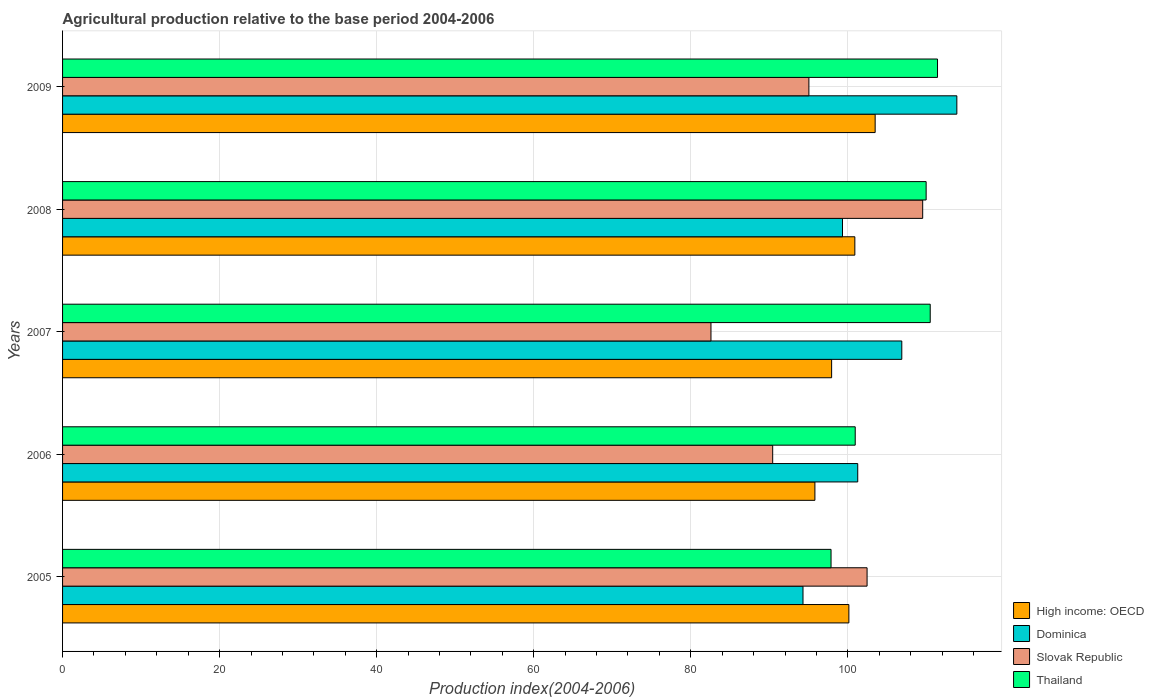How many groups of bars are there?
Your answer should be compact. 5. Are the number of bars per tick equal to the number of legend labels?
Keep it short and to the point. Yes. How many bars are there on the 3rd tick from the top?
Keep it short and to the point. 4. What is the agricultural production index in Slovak Republic in 2007?
Your answer should be compact. 82.57. Across all years, what is the maximum agricultural production index in Thailand?
Provide a succinct answer. 111.42. Across all years, what is the minimum agricultural production index in Dominica?
Provide a short and direct response. 94.29. In which year was the agricultural production index in Dominica minimum?
Offer a terse response. 2005. What is the total agricultural production index in Slovak Republic in the graph?
Offer a very short reply. 480.02. What is the difference between the agricultural production index in Slovak Republic in 2005 and that in 2009?
Your answer should be very brief. 7.41. What is the difference between the agricultural production index in Dominica in 2006 and the agricultural production index in High income: OECD in 2009?
Make the answer very short. -2.22. What is the average agricultural production index in Slovak Republic per year?
Keep it short and to the point. 96. In the year 2007, what is the difference between the agricultural production index in Thailand and agricultural production index in High income: OECD?
Offer a very short reply. 12.56. What is the ratio of the agricultural production index in Slovak Republic in 2005 to that in 2006?
Make the answer very short. 1.13. What is the difference between the highest and the second highest agricultural production index in Slovak Republic?
Your answer should be very brief. 7.08. What is the difference between the highest and the lowest agricultural production index in High income: OECD?
Provide a short and direct response. 7.67. Is it the case that in every year, the sum of the agricultural production index in High income: OECD and agricultural production index in Slovak Republic is greater than the sum of agricultural production index in Dominica and agricultural production index in Thailand?
Your answer should be compact. No. What does the 2nd bar from the top in 2005 represents?
Your answer should be very brief. Slovak Republic. What does the 4th bar from the bottom in 2009 represents?
Provide a short and direct response. Thailand. What is the difference between two consecutive major ticks on the X-axis?
Make the answer very short. 20. Are the values on the major ticks of X-axis written in scientific E-notation?
Ensure brevity in your answer.  No. Does the graph contain grids?
Your answer should be very brief. Yes. How many legend labels are there?
Your answer should be very brief. 4. What is the title of the graph?
Give a very brief answer. Agricultural production relative to the base period 2004-2006. Does "Congo (Republic)" appear as one of the legend labels in the graph?
Keep it short and to the point. No. What is the label or title of the X-axis?
Offer a terse response. Production index(2004-2006). What is the Production index(2004-2006) in High income: OECD in 2005?
Your answer should be very brief. 100.13. What is the Production index(2004-2006) of Dominica in 2005?
Ensure brevity in your answer.  94.29. What is the Production index(2004-2006) of Slovak Republic in 2005?
Your answer should be compact. 102.45. What is the Production index(2004-2006) in Thailand in 2005?
Provide a succinct answer. 97.86. What is the Production index(2004-2006) in High income: OECD in 2006?
Your response must be concise. 95.81. What is the Production index(2004-2006) of Dominica in 2006?
Make the answer very short. 101.26. What is the Production index(2004-2006) in Slovak Republic in 2006?
Make the answer very short. 90.43. What is the Production index(2004-2006) of Thailand in 2006?
Offer a very short reply. 100.94. What is the Production index(2004-2006) of High income: OECD in 2007?
Give a very brief answer. 97.93. What is the Production index(2004-2006) in Dominica in 2007?
Make the answer very short. 106.87. What is the Production index(2004-2006) of Slovak Republic in 2007?
Keep it short and to the point. 82.57. What is the Production index(2004-2006) of Thailand in 2007?
Your response must be concise. 110.49. What is the Production index(2004-2006) of High income: OECD in 2008?
Keep it short and to the point. 100.89. What is the Production index(2004-2006) of Dominica in 2008?
Make the answer very short. 99.32. What is the Production index(2004-2006) of Slovak Republic in 2008?
Offer a very short reply. 109.53. What is the Production index(2004-2006) in Thailand in 2008?
Make the answer very short. 109.97. What is the Production index(2004-2006) of High income: OECD in 2009?
Offer a terse response. 103.48. What is the Production index(2004-2006) of Dominica in 2009?
Provide a short and direct response. 113.88. What is the Production index(2004-2006) in Slovak Republic in 2009?
Your answer should be compact. 95.04. What is the Production index(2004-2006) in Thailand in 2009?
Offer a very short reply. 111.42. Across all years, what is the maximum Production index(2004-2006) of High income: OECD?
Provide a succinct answer. 103.48. Across all years, what is the maximum Production index(2004-2006) in Dominica?
Your response must be concise. 113.88. Across all years, what is the maximum Production index(2004-2006) of Slovak Republic?
Your response must be concise. 109.53. Across all years, what is the maximum Production index(2004-2006) in Thailand?
Offer a very short reply. 111.42. Across all years, what is the minimum Production index(2004-2006) of High income: OECD?
Give a very brief answer. 95.81. Across all years, what is the minimum Production index(2004-2006) of Dominica?
Ensure brevity in your answer.  94.29. Across all years, what is the minimum Production index(2004-2006) of Slovak Republic?
Offer a very short reply. 82.57. Across all years, what is the minimum Production index(2004-2006) of Thailand?
Provide a short and direct response. 97.86. What is the total Production index(2004-2006) in High income: OECD in the graph?
Your answer should be compact. 498.24. What is the total Production index(2004-2006) of Dominica in the graph?
Give a very brief answer. 515.62. What is the total Production index(2004-2006) in Slovak Republic in the graph?
Keep it short and to the point. 480.02. What is the total Production index(2004-2006) in Thailand in the graph?
Your response must be concise. 530.68. What is the difference between the Production index(2004-2006) in High income: OECD in 2005 and that in 2006?
Provide a short and direct response. 4.33. What is the difference between the Production index(2004-2006) of Dominica in 2005 and that in 2006?
Offer a terse response. -6.97. What is the difference between the Production index(2004-2006) in Slovak Republic in 2005 and that in 2006?
Ensure brevity in your answer.  12.02. What is the difference between the Production index(2004-2006) of Thailand in 2005 and that in 2006?
Offer a very short reply. -3.08. What is the difference between the Production index(2004-2006) in High income: OECD in 2005 and that in 2007?
Your answer should be compact. 2.2. What is the difference between the Production index(2004-2006) in Dominica in 2005 and that in 2007?
Your response must be concise. -12.58. What is the difference between the Production index(2004-2006) of Slovak Republic in 2005 and that in 2007?
Offer a terse response. 19.88. What is the difference between the Production index(2004-2006) in Thailand in 2005 and that in 2007?
Provide a succinct answer. -12.63. What is the difference between the Production index(2004-2006) in High income: OECD in 2005 and that in 2008?
Ensure brevity in your answer.  -0.76. What is the difference between the Production index(2004-2006) in Dominica in 2005 and that in 2008?
Your answer should be compact. -5.03. What is the difference between the Production index(2004-2006) of Slovak Republic in 2005 and that in 2008?
Offer a very short reply. -7.08. What is the difference between the Production index(2004-2006) of Thailand in 2005 and that in 2008?
Give a very brief answer. -12.11. What is the difference between the Production index(2004-2006) of High income: OECD in 2005 and that in 2009?
Your answer should be very brief. -3.35. What is the difference between the Production index(2004-2006) of Dominica in 2005 and that in 2009?
Your answer should be compact. -19.59. What is the difference between the Production index(2004-2006) of Slovak Republic in 2005 and that in 2009?
Your response must be concise. 7.41. What is the difference between the Production index(2004-2006) in Thailand in 2005 and that in 2009?
Your answer should be very brief. -13.56. What is the difference between the Production index(2004-2006) of High income: OECD in 2006 and that in 2007?
Ensure brevity in your answer.  -2.13. What is the difference between the Production index(2004-2006) in Dominica in 2006 and that in 2007?
Your answer should be very brief. -5.61. What is the difference between the Production index(2004-2006) of Slovak Republic in 2006 and that in 2007?
Your response must be concise. 7.86. What is the difference between the Production index(2004-2006) of Thailand in 2006 and that in 2007?
Give a very brief answer. -9.55. What is the difference between the Production index(2004-2006) of High income: OECD in 2006 and that in 2008?
Keep it short and to the point. -5.09. What is the difference between the Production index(2004-2006) in Dominica in 2006 and that in 2008?
Offer a very short reply. 1.94. What is the difference between the Production index(2004-2006) of Slovak Republic in 2006 and that in 2008?
Ensure brevity in your answer.  -19.1. What is the difference between the Production index(2004-2006) in Thailand in 2006 and that in 2008?
Provide a short and direct response. -9.03. What is the difference between the Production index(2004-2006) in High income: OECD in 2006 and that in 2009?
Provide a short and direct response. -7.67. What is the difference between the Production index(2004-2006) of Dominica in 2006 and that in 2009?
Offer a terse response. -12.62. What is the difference between the Production index(2004-2006) in Slovak Republic in 2006 and that in 2009?
Provide a succinct answer. -4.61. What is the difference between the Production index(2004-2006) of Thailand in 2006 and that in 2009?
Keep it short and to the point. -10.48. What is the difference between the Production index(2004-2006) of High income: OECD in 2007 and that in 2008?
Offer a very short reply. -2.96. What is the difference between the Production index(2004-2006) of Dominica in 2007 and that in 2008?
Your response must be concise. 7.55. What is the difference between the Production index(2004-2006) of Slovak Republic in 2007 and that in 2008?
Make the answer very short. -26.96. What is the difference between the Production index(2004-2006) in Thailand in 2007 and that in 2008?
Your answer should be compact. 0.52. What is the difference between the Production index(2004-2006) of High income: OECD in 2007 and that in 2009?
Your answer should be compact. -5.54. What is the difference between the Production index(2004-2006) in Dominica in 2007 and that in 2009?
Provide a short and direct response. -7.01. What is the difference between the Production index(2004-2006) of Slovak Republic in 2007 and that in 2009?
Offer a very short reply. -12.47. What is the difference between the Production index(2004-2006) in Thailand in 2007 and that in 2009?
Ensure brevity in your answer.  -0.93. What is the difference between the Production index(2004-2006) in High income: OECD in 2008 and that in 2009?
Offer a terse response. -2.59. What is the difference between the Production index(2004-2006) of Dominica in 2008 and that in 2009?
Offer a terse response. -14.56. What is the difference between the Production index(2004-2006) in Slovak Republic in 2008 and that in 2009?
Make the answer very short. 14.49. What is the difference between the Production index(2004-2006) in Thailand in 2008 and that in 2009?
Give a very brief answer. -1.45. What is the difference between the Production index(2004-2006) of High income: OECD in 2005 and the Production index(2004-2006) of Dominica in 2006?
Ensure brevity in your answer.  -1.13. What is the difference between the Production index(2004-2006) in High income: OECD in 2005 and the Production index(2004-2006) in Slovak Republic in 2006?
Your response must be concise. 9.7. What is the difference between the Production index(2004-2006) of High income: OECD in 2005 and the Production index(2004-2006) of Thailand in 2006?
Your answer should be very brief. -0.81. What is the difference between the Production index(2004-2006) in Dominica in 2005 and the Production index(2004-2006) in Slovak Republic in 2006?
Give a very brief answer. 3.86. What is the difference between the Production index(2004-2006) in Dominica in 2005 and the Production index(2004-2006) in Thailand in 2006?
Ensure brevity in your answer.  -6.65. What is the difference between the Production index(2004-2006) of Slovak Republic in 2005 and the Production index(2004-2006) of Thailand in 2006?
Provide a short and direct response. 1.51. What is the difference between the Production index(2004-2006) in High income: OECD in 2005 and the Production index(2004-2006) in Dominica in 2007?
Your answer should be very brief. -6.74. What is the difference between the Production index(2004-2006) in High income: OECD in 2005 and the Production index(2004-2006) in Slovak Republic in 2007?
Provide a short and direct response. 17.56. What is the difference between the Production index(2004-2006) in High income: OECD in 2005 and the Production index(2004-2006) in Thailand in 2007?
Provide a succinct answer. -10.36. What is the difference between the Production index(2004-2006) of Dominica in 2005 and the Production index(2004-2006) of Slovak Republic in 2007?
Provide a succinct answer. 11.72. What is the difference between the Production index(2004-2006) of Dominica in 2005 and the Production index(2004-2006) of Thailand in 2007?
Make the answer very short. -16.2. What is the difference between the Production index(2004-2006) of Slovak Republic in 2005 and the Production index(2004-2006) of Thailand in 2007?
Provide a short and direct response. -8.04. What is the difference between the Production index(2004-2006) in High income: OECD in 2005 and the Production index(2004-2006) in Dominica in 2008?
Provide a succinct answer. 0.81. What is the difference between the Production index(2004-2006) of High income: OECD in 2005 and the Production index(2004-2006) of Slovak Republic in 2008?
Your answer should be compact. -9.4. What is the difference between the Production index(2004-2006) in High income: OECD in 2005 and the Production index(2004-2006) in Thailand in 2008?
Offer a very short reply. -9.84. What is the difference between the Production index(2004-2006) in Dominica in 2005 and the Production index(2004-2006) in Slovak Republic in 2008?
Your answer should be very brief. -15.24. What is the difference between the Production index(2004-2006) of Dominica in 2005 and the Production index(2004-2006) of Thailand in 2008?
Offer a very short reply. -15.68. What is the difference between the Production index(2004-2006) in Slovak Republic in 2005 and the Production index(2004-2006) in Thailand in 2008?
Offer a very short reply. -7.52. What is the difference between the Production index(2004-2006) of High income: OECD in 2005 and the Production index(2004-2006) of Dominica in 2009?
Make the answer very short. -13.75. What is the difference between the Production index(2004-2006) in High income: OECD in 2005 and the Production index(2004-2006) in Slovak Republic in 2009?
Make the answer very short. 5.09. What is the difference between the Production index(2004-2006) of High income: OECD in 2005 and the Production index(2004-2006) of Thailand in 2009?
Give a very brief answer. -11.29. What is the difference between the Production index(2004-2006) of Dominica in 2005 and the Production index(2004-2006) of Slovak Republic in 2009?
Give a very brief answer. -0.75. What is the difference between the Production index(2004-2006) in Dominica in 2005 and the Production index(2004-2006) in Thailand in 2009?
Your response must be concise. -17.13. What is the difference between the Production index(2004-2006) in Slovak Republic in 2005 and the Production index(2004-2006) in Thailand in 2009?
Offer a terse response. -8.97. What is the difference between the Production index(2004-2006) in High income: OECD in 2006 and the Production index(2004-2006) in Dominica in 2007?
Make the answer very short. -11.06. What is the difference between the Production index(2004-2006) in High income: OECD in 2006 and the Production index(2004-2006) in Slovak Republic in 2007?
Make the answer very short. 13.24. What is the difference between the Production index(2004-2006) of High income: OECD in 2006 and the Production index(2004-2006) of Thailand in 2007?
Offer a terse response. -14.68. What is the difference between the Production index(2004-2006) in Dominica in 2006 and the Production index(2004-2006) in Slovak Republic in 2007?
Offer a terse response. 18.69. What is the difference between the Production index(2004-2006) in Dominica in 2006 and the Production index(2004-2006) in Thailand in 2007?
Keep it short and to the point. -9.23. What is the difference between the Production index(2004-2006) of Slovak Republic in 2006 and the Production index(2004-2006) of Thailand in 2007?
Offer a terse response. -20.06. What is the difference between the Production index(2004-2006) in High income: OECD in 2006 and the Production index(2004-2006) in Dominica in 2008?
Your response must be concise. -3.51. What is the difference between the Production index(2004-2006) of High income: OECD in 2006 and the Production index(2004-2006) of Slovak Republic in 2008?
Offer a terse response. -13.72. What is the difference between the Production index(2004-2006) of High income: OECD in 2006 and the Production index(2004-2006) of Thailand in 2008?
Offer a very short reply. -14.16. What is the difference between the Production index(2004-2006) of Dominica in 2006 and the Production index(2004-2006) of Slovak Republic in 2008?
Your answer should be compact. -8.27. What is the difference between the Production index(2004-2006) in Dominica in 2006 and the Production index(2004-2006) in Thailand in 2008?
Offer a terse response. -8.71. What is the difference between the Production index(2004-2006) of Slovak Republic in 2006 and the Production index(2004-2006) of Thailand in 2008?
Offer a very short reply. -19.54. What is the difference between the Production index(2004-2006) of High income: OECD in 2006 and the Production index(2004-2006) of Dominica in 2009?
Offer a very short reply. -18.07. What is the difference between the Production index(2004-2006) of High income: OECD in 2006 and the Production index(2004-2006) of Slovak Republic in 2009?
Keep it short and to the point. 0.77. What is the difference between the Production index(2004-2006) in High income: OECD in 2006 and the Production index(2004-2006) in Thailand in 2009?
Make the answer very short. -15.61. What is the difference between the Production index(2004-2006) in Dominica in 2006 and the Production index(2004-2006) in Slovak Republic in 2009?
Provide a short and direct response. 6.22. What is the difference between the Production index(2004-2006) of Dominica in 2006 and the Production index(2004-2006) of Thailand in 2009?
Ensure brevity in your answer.  -10.16. What is the difference between the Production index(2004-2006) in Slovak Republic in 2006 and the Production index(2004-2006) in Thailand in 2009?
Your answer should be very brief. -20.99. What is the difference between the Production index(2004-2006) of High income: OECD in 2007 and the Production index(2004-2006) of Dominica in 2008?
Offer a very short reply. -1.39. What is the difference between the Production index(2004-2006) in High income: OECD in 2007 and the Production index(2004-2006) in Slovak Republic in 2008?
Ensure brevity in your answer.  -11.6. What is the difference between the Production index(2004-2006) of High income: OECD in 2007 and the Production index(2004-2006) of Thailand in 2008?
Your answer should be compact. -12.04. What is the difference between the Production index(2004-2006) in Dominica in 2007 and the Production index(2004-2006) in Slovak Republic in 2008?
Make the answer very short. -2.66. What is the difference between the Production index(2004-2006) in Dominica in 2007 and the Production index(2004-2006) in Thailand in 2008?
Give a very brief answer. -3.1. What is the difference between the Production index(2004-2006) of Slovak Republic in 2007 and the Production index(2004-2006) of Thailand in 2008?
Provide a short and direct response. -27.4. What is the difference between the Production index(2004-2006) of High income: OECD in 2007 and the Production index(2004-2006) of Dominica in 2009?
Your response must be concise. -15.95. What is the difference between the Production index(2004-2006) in High income: OECD in 2007 and the Production index(2004-2006) in Slovak Republic in 2009?
Offer a very short reply. 2.89. What is the difference between the Production index(2004-2006) in High income: OECD in 2007 and the Production index(2004-2006) in Thailand in 2009?
Your response must be concise. -13.49. What is the difference between the Production index(2004-2006) in Dominica in 2007 and the Production index(2004-2006) in Slovak Republic in 2009?
Your answer should be very brief. 11.83. What is the difference between the Production index(2004-2006) of Dominica in 2007 and the Production index(2004-2006) of Thailand in 2009?
Keep it short and to the point. -4.55. What is the difference between the Production index(2004-2006) of Slovak Republic in 2007 and the Production index(2004-2006) of Thailand in 2009?
Make the answer very short. -28.85. What is the difference between the Production index(2004-2006) of High income: OECD in 2008 and the Production index(2004-2006) of Dominica in 2009?
Keep it short and to the point. -12.99. What is the difference between the Production index(2004-2006) in High income: OECD in 2008 and the Production index(2004-2006) in Slovak Republic in 2009?
Offer a terse response. 5.85. What is the difference between the Production index(2004-2006) of High income: OECD in 2008 and the Production index(2004-2006) of Thailand in 2009?
Make the answer very short. -10.53. What is the difference between the Production index(2004-2006) in Dominica in 2008 and the Production index(2004-2006) in Slovak Republic in 2009?
Your response must be concise. 4.28. What is the difference between the Production index(2004-2006) in Dominica in 2008 and the Production index(2004-2006) in Thailand in 2009?
Your answer should be compact. -12.1. What is the difference between the Production index(2004-2006) in Slovak Republic in 2008 and the Production index(2004-2006) in Thailand in 2009?
Make the answer very short. -1.89. What is the average Production index(2004-2006) of High income: OECD per year?
Your answer should be very brief. 99.65. What is the average Production index(2004-2006) of Dominica per year?
Provide a short and direct response. 103.12. What is the average Production index(2004-2006) of Slovak Republic per year?
Give a very brief answer. 96. What is the average Production index(2004-2006) of Thailand per year?
Give a very brief answer. 106.14. In the year 2005, what is the difference between the Production index(2004-2006) of High income: OECD and Production index(2004-2006) of Dominica?
Keep it short and to the point. 5.84. In the year 2005, what is the difference between the Production index(2004-2006) of High income: OECD and Production index(2004-2006) of Slovak Republic?
Your response must be concise. -2.32. In the year 2005, what is the difference between the Production index(2004-2006) of High income: OECD and Production index(2004-2006) of Thailand?
Make the answer very short. 2.27. In the year 2005, what is the difference between the Production index(2004-2006) in Dominica and Production index(2004-2006) in Slovak Republic?
Your answer should be compact. -8.16. In the year 2005, what is the difference between the Production index(2004-2006) in Dominica and Production index(2004-2006) in Thailand?
Offer a terse response. -3.57. In the year 2005, what is the difference between the Production index(2004-2006) in Slovak Republic and Production index(2004-2006) in Thailand?
Give a very brief answer. 4.59. In the year 2006, what is the difference between the Production index(2004-2006) of High income: OECD and Production index(2004-2006) of Dominica?
Offer a terse response. -5.45. In the year 2006, what is the difference between the Production index(2004-2006) in High income: OECD and Production index(2004-2006) in Slovak Republic?
Offer a terse response. 5.38. In the year 2006, what is the difference between the Production index(2004-2006) of High income: OECD and Production index(2004-2006) of Thailand?
Your answer should be compact. -5.13. In the year 2006, what is the difference between the Production index(2004-2006) of Dominica and Production index(2004-2006) of Slovak Republic?
Provide a short and direct response. 10.83. In the year 2006, what is the difference between the Production index(2004-2006) in Dominica and Production index(2004-2006) in Thailand?
Give a very brief answer. 0.32. In the year 2006, what is the difference between the Production index(2004-2006) of Slovak Republic and Production index(2004-2006) of Thailand?
Offer a terse response. -10.51. In the year 2007, what is the difference between the Production index(2004-2006) of High income: OECD and Production index(2004-2006) of Dominica?
Keep it short and to the point. -8.94. In the year 2007, what is the difference between the Production index(2004-2006) of High income: OECD and Production index(2004-2006) of Slovak Republic?
Your answer should be very brief. 15.36. In the year 2007, what is the difference between the Production index(2004-2006) in High income: OECD and Production index(2004-2006) in Thailand?
Ensure brevity in your answer.  -12.56. In the year 2007, what is the difference between the Production index(2004-2006) of Dominica and Production index(2004-2006) of Slovak Republic?
Your response must be concise. 24.3. In the year 2007, what is the difference between the Production index(2004-2006) of Dominica and Production index(2004-2006) of Thailand?
Provide a short and direct response. -3.62. In the year 2007, what is the difference between the Production index(2004-2006) of Slovak Republic and Production index(2004-2006) of Thailand?
Offer a very short reply. -27.92. In the year 2008, what is the difference between the Production index(2004-2006) in High income: OECD and Production index(2004-2006) in Dominica?
Offer a very short reply. 1.57. In the year 2008, what is the difference between the Production index(2004-2006) of High income: OECD and Production index(2004-2006) of Slovak Republic?
Ensure brevity in your answer.  -8.64. In the year 2008, what is the difference between the Production index(2004-2006) in High income: OECD and Production index(2004-2006) in Thailand?
Provide a short and direct response. -9.08. In the year 2008, what is the difference between the Production index(2004-2006) in Dominica and Production index(2004-2006) in Slovak Republic?
Make the answer very short. -10.21. In the year 2008, what is the difference between the Production index(2004-2006) of Dominica and Production index(2004-2006) of Thailand?
Your answer should be compact. -10.65. In the year 2008, what is the difference between the Production index(2004-2006) in Slovak Republic and Production index(2004-2006) in Thailand?
Provide a short and direct response. -0.44. In the year 2009, what is the difference between the Production index(2004-2006) of High income: OECD and Production index(2004-2006) of Dominica?
Your answer should be compact. -10.4. In the year 2009, what is the difference between the Production index(2004-2006) of High income: OECD and Production index(2004-2006) of Slovak Republic?
Offer a terse response. 8.44. In the year 2009, what is the difference between the Production index(2004-2006) in High income: OECD and Production index(2004-2006) in Thailand?
Your answer should be compact. -7.94. In the year 2009, what is the difference between the Production index(2004-2006) in Dominica and Production index(2004-2006) in Slovak Republic?
Provide a short and direct response. 18.84. In the year 2009, what is the difference between the Production index(2004-2006) in Dominica and Production index(2004-2006) in Thailand?
Ensure brevity in your answer.  2.46. In the year 2009, what is the difference between the Production index(2004-2006) in Slovak Republic and Production index(2004-2006) in Thailand?
Offer a very short reply. -16.38. What is the ratio of the Production index(2004-2006) of High income: OECD in 2005 to that in 2006?
Your answer should be compact. 1.05. What is the ratio of the Production index(2004-2006) in Dominica in 2005 to that in 2006?
Provide a short and direct response. 0.93. What is the ratio of the Production index(2004-2006) in Slovak Republic in 2005 to that in 2006?
Your response must be concise. 1.13. What is the ratio of the Production index(2004-2006) in Thailand in 2005 to that in 2006?
Offer a terse response. 0.97. What is the ratio of the Production index(2004-2006) of High income: OECD in 2005 to that in 2007?
Offer a terse response. 1.02. What is the ratio of the Production index(2004-2006) in Dominica in 2005 to that in 2007?
Your response must be concise. 0.88. What is the ratio of the Production index(2004-2006) of Slovak Republic in 2005 to that in 2007?
Ensure brevity in your answer.  1.24. What is the ratio of the Production index(2004-2006) of Thailand in 2005 to that in 2007?
Keep it short and to the point. 0.89. What is the ratio of the Production index(2004-2006) of Dominica in 2005 to that in 2008?
Your answer should be very brief. 0.95. What is the ratio of the Production index(2004-2006) of Slovak Republic in 2005 to that in 2008?
Ensure brevity in your answer.  0.94. What is the ratio of the Production index(2004-2006) of Thailand in 2005 to that in 2008?
Your response must be concise. 0.89. What is the ratio of the Production index(2004-2006) in Dominica in 2005 to that in 2009?
Your response must be concise. 0.83. What is the ratio of the Production index(2004-2006) of Slovak Republic in 2005 to that in 2009?
Keep it short and to the point. 1.08. What is the ratio of the Production index(2004-2006) in Thailand in 2005 to that in 2009?
Your answer should be compact. 0.88. What is the ratio of the Production index(2004-2006) of High income: OECD in 2006 to that in 2007?
Make the answer very short. 0.98. What is the ratio of the Production index(2004-2006) in Dominica in 2006 to that in 2007?
Make the answer very short. 0.95. What is the ratio of the Production index(2004-2006) of Slovak Republic in 2006 to that in 2007?
Give a very brief answer. 1.1. What is the ratio of the Production index(2004-2006) of Thailand in 2006 to that in 2007?
Provide a short and direct response. 0.91. What is the ratio of the Production index(2004-2006) of High income: OECD in 2006 to that in 2008?
Your response must be concise. 0.95. What is the ratio of the Production index(2004-2006) of Dominica in 2006 to that in 2008?
Provide a short and direct response. 1.02. What is the ratio of the Production index(2004-2006) in Slovak Republic in 2006 to that in 2008?
Offer a very short reply. 0.83. What is the ratio of the Production index(2004-2006) of Thailand in 2006 to that in 2008?
Offer a terse response. 0.92. What is the ratio of the Production index(2004-2006) in High income: OECD in 2006 to that in 2009?
Provide a succinct answer. 0.93. What is the ratio of the Production index(2004-2006) of Dominica in 2006 to that in 2009?
Give a very brief answer. 0.89. What is the ratio of the Production index(2004-2006) of Slovak Republic in 2006 to that in 2009?
Ensure brevity in your answer.  0.95. What is the ratio of the Production index(2004-2006) of Thailand in 2006 to that in 2009?
Ensure brevity in your answer.  0.91. What is the ratio of the Production index(2004-2006) in High income: OECD in 2007 to that in 2008?
Keep it short and to the point. 0.97. What is the ratio of the Production index(2004-2006) in Dominica in 2007 to that in 2008?
Ensure brevity in your answer.  1.08. What is the ratio of the Production index(2004-2006) of Slovak Republic in 2007 to that in 2008?
Your answer should be compact. 0.75. What is the ratio of the Production index(2004-2006) in High income: OECD in 2007 to that in 2009?
Make the answer very short. 0.95. What is the ratio of the Production index(2004-2006) of Dominica in 2007 to that in 2009?
Keep it short and to the point. 0.94. What is the ratio of the Production index(2004-2006) of Slovak Republic in 2007 to that in 2009?
Give a very brief answer. 0.87. What is the ratio of the Production index(2004-2006) of High income: OECD in 2008 to that in 2009?
Your answer should be very brief. 0.97. What is the ratio of the Production index(2004-2006) in Dominica in 2008 to that in 2009?
Provide a short and direct response. 0.87. What is the ratio of the Production index(2004-2006) in Slovak Republic in 2008 to that in 2009?
Give a very brief answer. 1.15. What is the difference between the highest and the second highest Production index(2004-2006) of High income: OECD?
Offer a very short reply. 2.59. What is the difference between the highest and the second highest Production index(2004-2006) in Dominica?
Keep it short and to the point. 7.01. What is the difference between the highest and the second highest Production index(2004-2006) in Slovak Republic?
Offer a very short reply. 7.08. What is the difference between the highest and the lowest Production index(2004-2006) of High income: OECD?
Offer a very short reply. 7.67. What is the difference between the highest and the lowest Production index(2004-2006) of Dominica?
Make the answer very short. 19.59. What is the difference between the highest and the lowest Production index(2004-2006) of Slovak Republic?
Provide a succinct answer. 26.96. What is the difference between the highest and the lowest Production index(2004-2006) of Thailand?
Offer a very short reply. 13.56. 